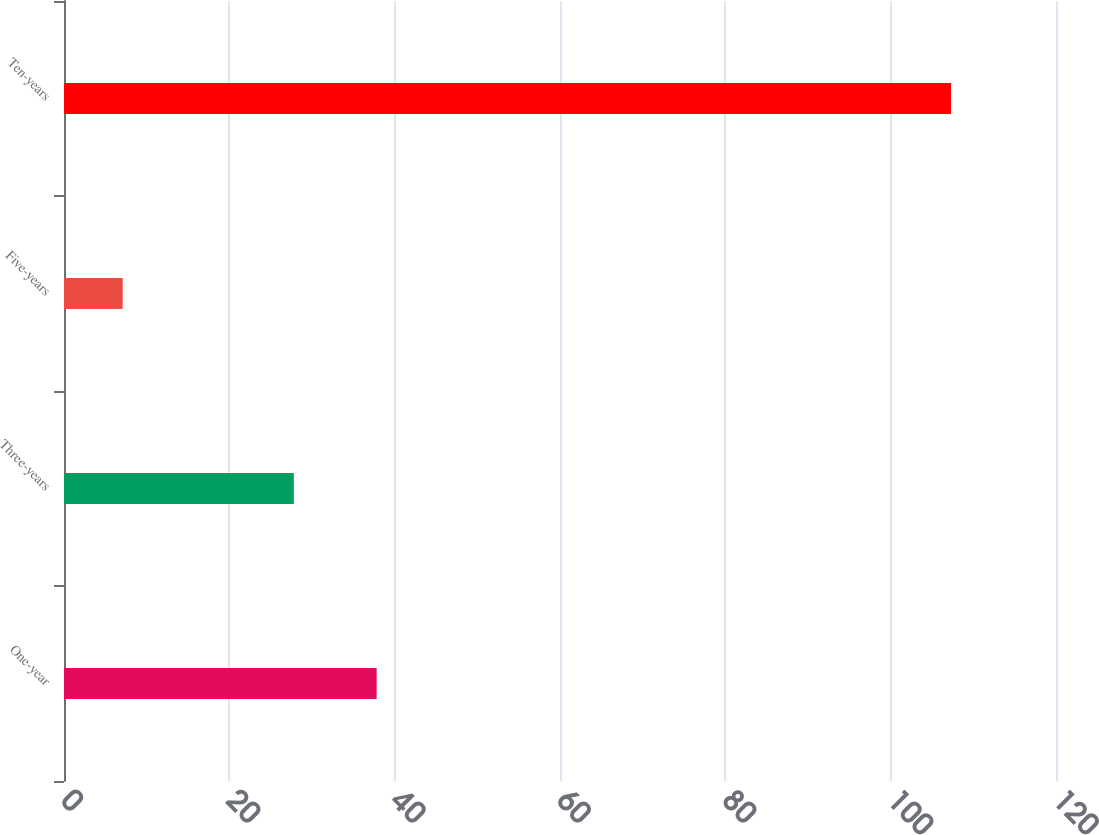Convert chart. <chart><loc_0><loc_0><loc_500><loc_500><bar_chart><fcel>One-year<fcel>Three-years<fcel>Five-years<fcel>Ten-years<nl><fcel>37.82<fcel>27.8<fcel>7.1<fcel>107.3<nl></chart> 